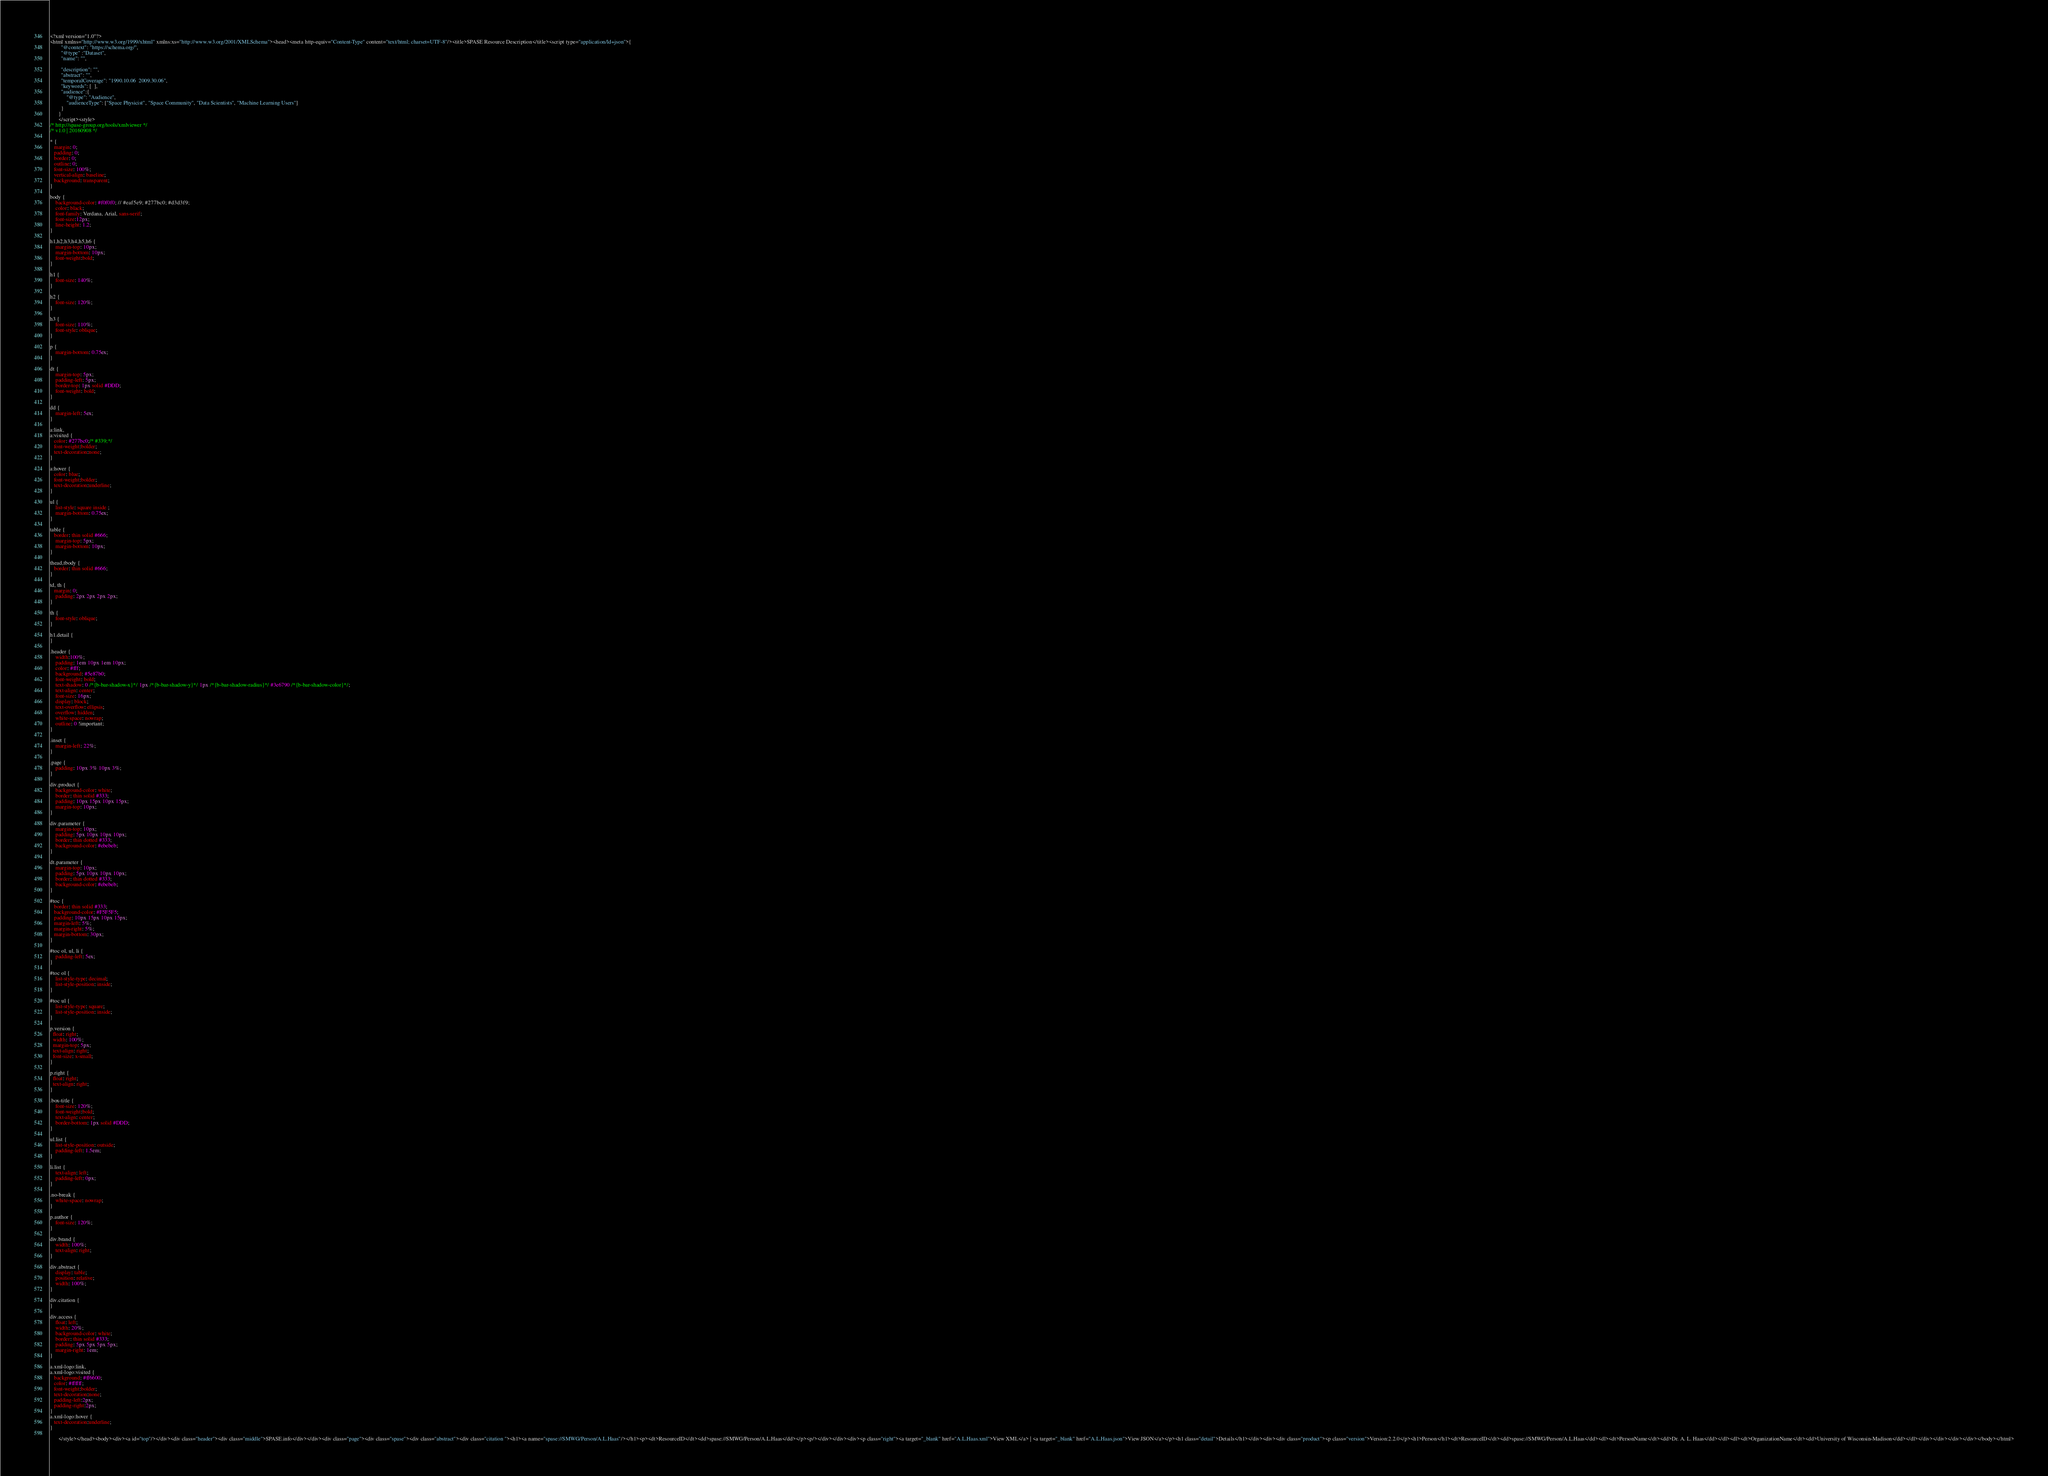Convert code to text. <code><loc_0><loc_0><loc_500><loc_500><_HTML_><?xml version="1.0"?>
<html xmlns="http://www.w3.org/1999/xhtml" xmlns:xs="http://www.w3.org/2001/XMLSchema"><head><meta http-equiv="Content-Type" content="text/html; charset=UTF-8"/><title>SPASE Resource Description</title><script type="application/ld+json">{
		"@context": "https://schema.org/",
		"@type" :"Dataset",
		"name": "",
     
 		"description": "",
		"abstract": "",
		"temporalCoverage": "1990.10.06  2009.30.06",
		"keywords": [  ],
        "audience":{
            "@type": "Audience",
            "audienceType": ["Space Physicist", "Space Community", "Data Scientists", "Machine Learning Users"]
        }
	  }
	  </script><style>
/* http://spase-group.org/tools/xmlviewer */
/* v1.0 | 20160908 */

* {
   margin: 0;
   padding: 0;
   border: 0;
   outline: 0;
   font-size: 100%;
   vertical-align: baseline;
   background: transparent;
}

body {
	background-color: #f0f0f0; // #eaf5e9; #277bc0; #d3d3f9;
	color: black;
	font-family: Verdana, Arial, sans-serif; 
	font-size:12px; 
	line-height: 1.2;
}
 
h1,h2,h3,h4,h5,h6 {
	margin-top: 10px;
	margin-bottom: 10px;
	font-weight:bold;
}

h1 {
	font-size: 140%;
}

h2 {
	font-size: 120%;
}

h3 {
	font-size: 110%;
	font-style: oblique;
}

p {
	margin-bottom: 0.75ex;
}

dt {
	margin-top: 5px;
	padding-left: 5px;
	border-top: 1px solid #DDD;
	font-weight: bold;
}

dd {
	margin-left: 5ex;
}

a:link,
a:visited {
   color: #277bc0;/* #339;*/
   font-weight:bolder; 
   text-decoration:none; 
}

a:hover {
   color: blue;
   font-weight:bolder; 
   text-decoration:underline; 
}

ul {
	list-style: square inside ;
	margin-bottom: 0.75ex;
}

table {
   border: thin solid #666;
	margin-top: 5px;
	margin-bottom: 10px;
}

thead,tbody {
   border: thin solid #666;
}

td, th {
   margin: 0;
	padding: 2px 2px 2px 2px;
}

th {
	font-style: oblique;
}

h1.detail {
}

.header {
	width:100%;
	padding: 1em 10px 1em 10px;
	color: #fff;
	background: #5e87b0;
	font-weight: bold;
	text-shadow: 0 /*{b-bar-shadow-x}*/ 1px /*{b-bar-shadow-y}*/ 1px /*{b-bar-shadow-radius}*/ #3e6790 /*{b-bar-shadow-color}*/;
	text-align: center;
	font-size: 16px;
	display: block;
	text-overflow: ellipsis;
	overflow: hidden;
	white-space: nowrap;
	outline: 0 !important;
}

.inset {
	margin-left: 22%;
}

.page {
	padding: 10px 3% 10px 3%;
}

div.product {
	background-color: white;
	border: thin solid #333;
	padding: 10px 15px 10px 15px;
	margin-top: 10px;
}

div.parameter {
	margin-top: 10px;
	padding: 5px 10px 10px 10px;
	border: thin dotted #333;
	background-color: #ebebeb;
}

dt.parameter {
	margin-top: 10px;
	padding: 5px 10px 10px 10px;
	border: thin dotted #333;
	background-color: #ebebeb;
}

#toc {
   border: thin solid #333;
   background-color: #F5F5F5; 
   padding: 10px 15px 10px 15px;
   margin-left: 5%;
   margin-right: 5%;
   margin-bottom: 30px;
}

#toc ol, ul, li {
	padding-left: 5ex;
}

#toc ol {
	list-style-type: decimal;
	list-style-position: inside; 
}

#toc ul {
	list-style-type: square;
	list-style-position: inside; 
}

p.version {
  float: right;
  width: 100%;
  margin-top: 5px;
  text-align: right;
  font-size: x-small;
}

p.right {
  float: right;
  text-align: right;
}

.box-title {
	font-size: 120%;
	font-weight:bold;
	text-align: center;
	border-bottom: 1px solid #DDD;
}

ul.list {
	list-style-position: outside;
	padding-left: 1.5em;
}

li.list {
	text-align: left;
	padding-left: 0px;
}

.no-break {
	white-space: nowrap;
}

p.author {
	font-size: 120%;
}

div.brand {
	width: 100%;
	text-align: right;
}

div.abstract {
	display: table;
	position: relative;
	width: 100%;
}

div.citation {
}

div.access {
	float: left;
	width: 20%;
	background-color: white;
	border: thin solid #333;
	padding: 5px 5px 5px 5px;
	margin-right: 1em;
}

a.xml-logo:link,
a.xml-logo:visited {
   background: #ff6600;
   color: #ffffff;
   font-weight:bolder; 
   text-decoration:none; 
   padding-left:2px;
   padding-right:2px;
}
a.xml-logo:hover {
   text-decoration:underline; 
}

	  </style></head><body><div><a id="top"/></div><div class="header"><div class="middle">SPASE.info</div></div><div class="page"><div class="spase"><div class="abstract"><div class="citation "><h1><a name="spase://SMWG/Person/A.L.Haas"/></h1><p><dt>ResourceID</dt><dd>spase://SMWG/Person/A.L.Haas</dd></p><p/></div></div><div><p class="right"><a target="_blank" href="A.L.Haas.xml">View XML</a> | <a target="_blank" href="A.L.Haas.json">View JSON</a></p><h1 class="detail">Details</h1></div><div><div class="product"><p class="version">Version:2.2.0</p><h1>Person</h1><dt>ResourceID</dt><dd>spase://SMWG/Person/A.L.Haas</dd><dl><dt>PersonName</dt><dd>Dr. A. L. Haas</dd></dl><dl><dt>OrganizationName</dt><dd>University of Wisconsin-Madison</dd></dl></div></div></div></div></body></html>
</code> 